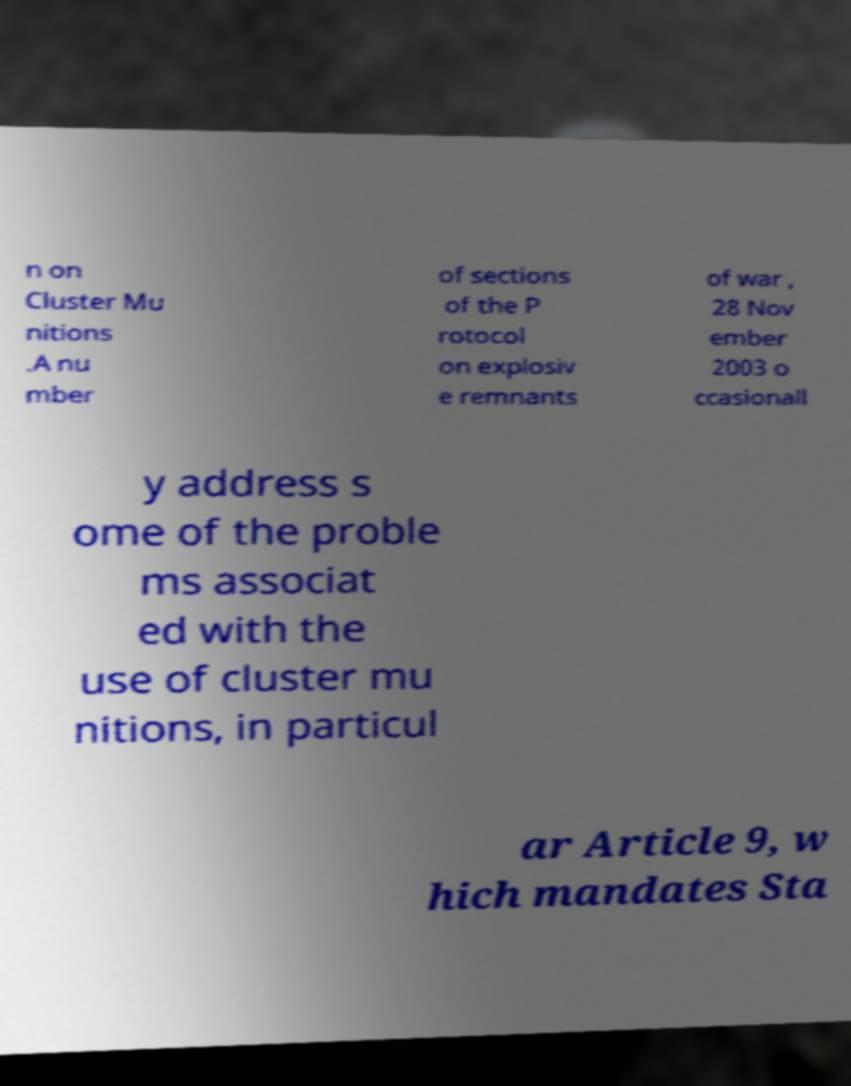Could you assist in decoding the text presented in this image and type it out clearly? n on Cluster Mu nitions .A nu mber of sections of the P rotocol on explosiv e remnants of war , 28 Nov ember 2003 o ccasionall y address s ome of the proble ms associat ed with the use of cluster mu nitions, in particul ar Article 9, w hich mandates Sta 